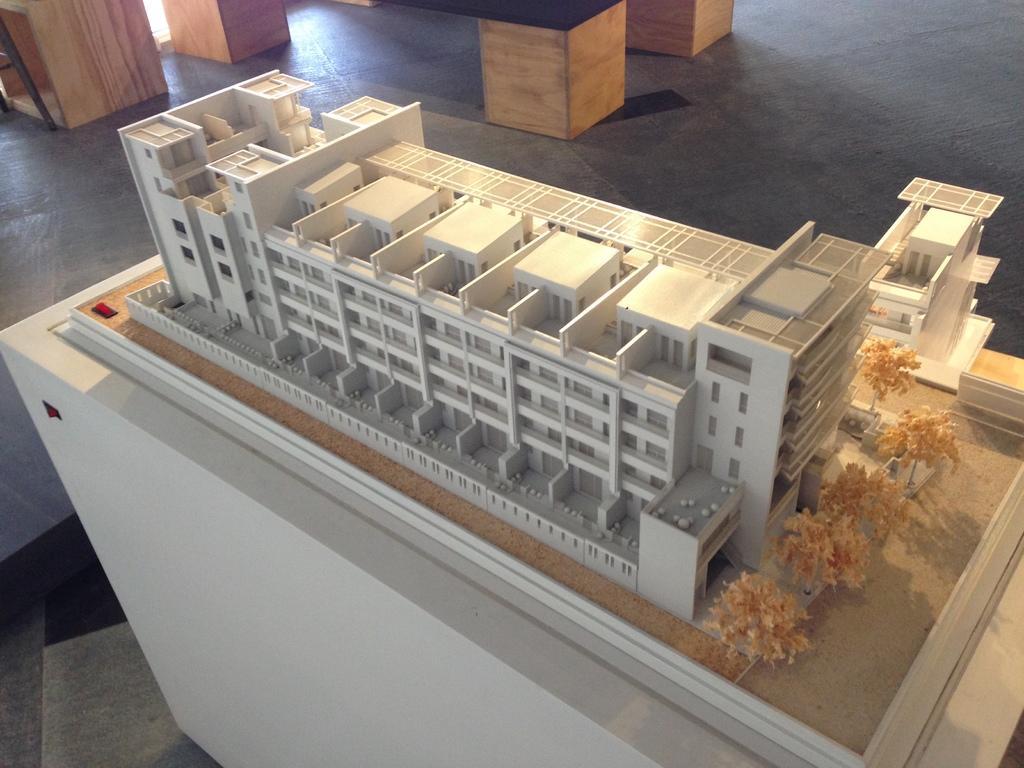Describe this image in one or two sentences. In this picture we can see one building plane is placed on the table. 